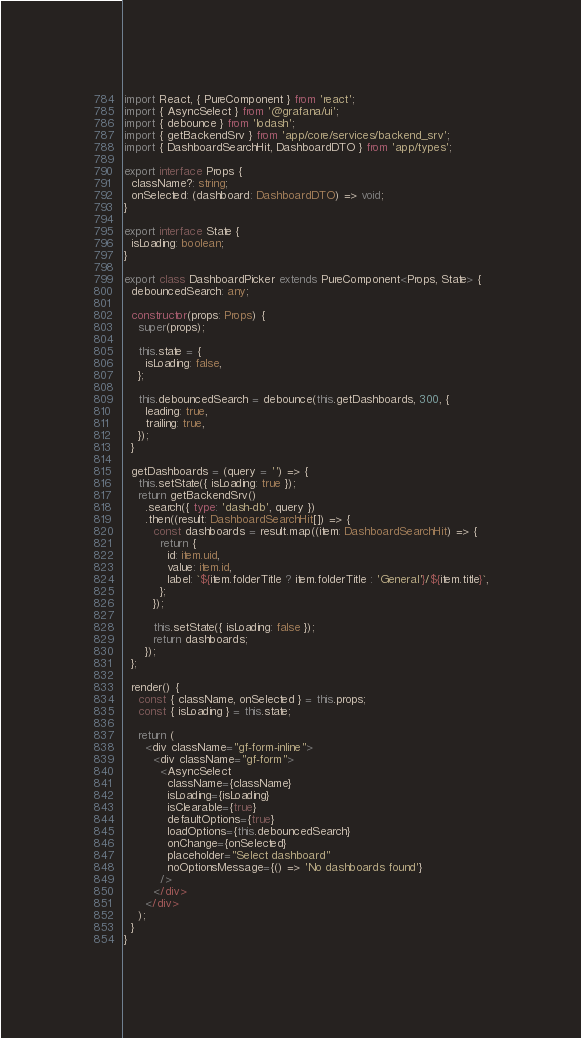Convert code to text. <code><loc_0><loc_0><loc_500><loc_500><_TypeScript_>import React, { PureComponent } from 'react';
import { AsyncSelect } from '@grafana/ui';
import { debounce } from 'lodash';
import { getBackendSrv } from 'app/core/services/backend_srv';
import { DashboardSearchHit, DashboardDTO } from 'app/types';

export interface Props {
  className?: string;
  onSelected: (dashboard: DashboardDTO) => void;
}

export interface State {
  isLoading: boolean;
}

export class DashboardPicker extends PureComponent<Props, State> {
  debouncedSearch: any;

  constructor(props: Props) {
    super(props);

    this.state = {
      isLoading: false,
    };

    this.debouncedSearch = debounce(this.getDashboards, 300, {
      leading: true,
      trailing: true,
    });
  }

  getDashboards = (query = '') => {
    this.setState({ isLoading: true });
    return getBackendSrv()
      .search({ type: 'dash-db', query })
      .then((result: DashboardSearchHit[]) => {
        const dashboards = result.map((item: DashboardSearchHit) => {
          return {
            id: item.uid,
            value: item.id,
            label: `${item.folderTitle ? item.folderTitle : 'General'}/${item.title}`,
          };
        });

        this.setState({ isLoading: false });
        return dashboards;
      });
  };

  render() {
    const { className, onSelected } = this.props;
    const { isLoading } = this.state;

    return (
      <div className="gf-form-inline">
        <div className="gf-form">
          <AsyncSelect
            className={className}
            isLoading={isLoading}
            isClearable={true}
            defaultOptions={true}
            loadOptions={this.debouncedSearch}
            onChange={onSelected}
            placeholder="Select dashboard"
            noOptionsMessage={() => 'No dashboards found'}
          />
        </div>
      </div>
    );
  }
}
</code> 